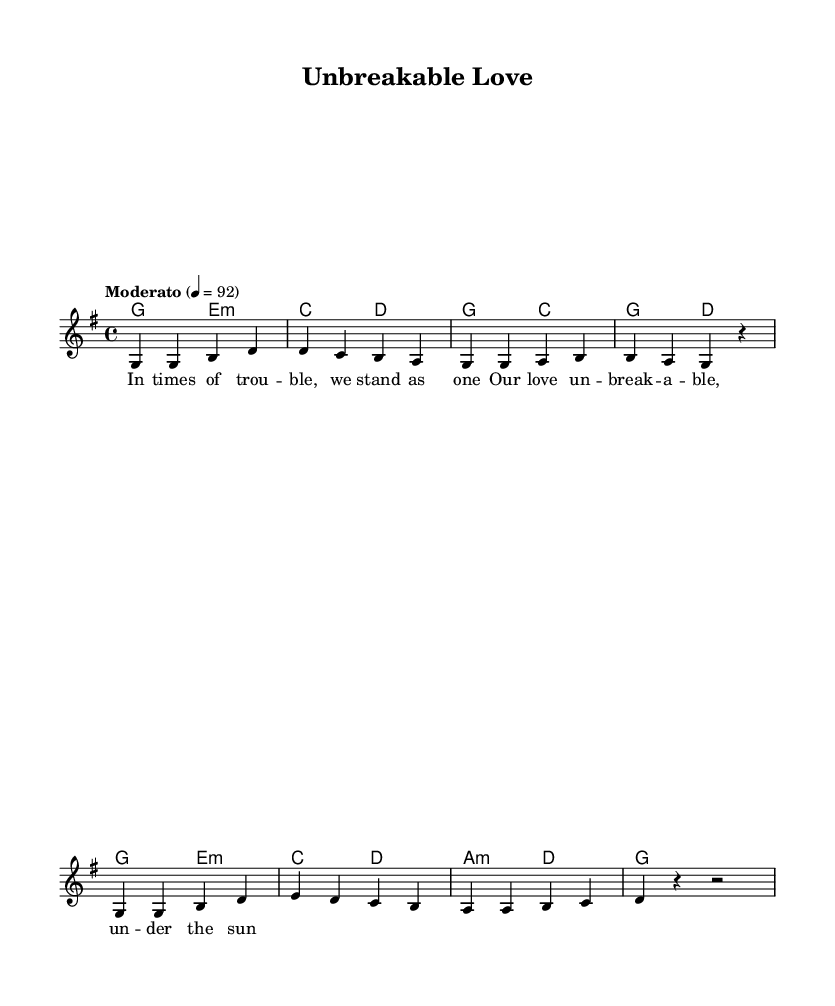What is the key signature of this music? The key signature is G major, which has one sharp (F#). This can be identified by looking at the key signature indicated at the beginning of the staff.
Answer: G major What is the time signature of this music? The time signature is 4/4, which shows that there are four beats in each measure and the quarter note gets one beat. This is typically indicated at the beginning of the staff.
Answer: 4/4 What is the tempo marking for this piece? The tempo marking is "Moderato," which indicates a moderate speed for the music. It can be found above the staff as part of the header information.
Answer: Moderato What is the primary theme expressed in the lyrics? The primary theme expressed in the lyrics is unity in challenging times, emphasizing unbreakable love. This can be inferred from the text of the verse, which speaks of standing together during trouble.
Answer: Unity How many measures are there in the melody section? There are eight measures in the melody section. This can be confirmed by counting the individual musical segments separated by bar lines in the melody part.
Answer: Eight What types of chords are used in the harmonies? The harmonies primarily include major and minor chords, as indicated by the chord names like G major, E minor, and A minor. This can be seen in the chord names listed underneath the staff.
Answer: Major and minor Are there any repeated phrases in the melody? Yes, the phrase "g g" is repeated in the melody, appearing at the start of the first and fifth measures. This can be identified by examining the melody notes and their arrangement.
Answer: Yes 